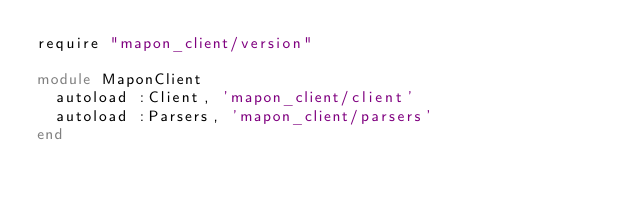Convert code to text. <code><loc_0><loc_0><loc_500><loc_500><_Ruby_>require "mapon_client/version"

module MaponClient
  autoload :Client, 'mapon_client/client'
  autoload :Parsers, 'mapon_client/parsers'
end
</code> 